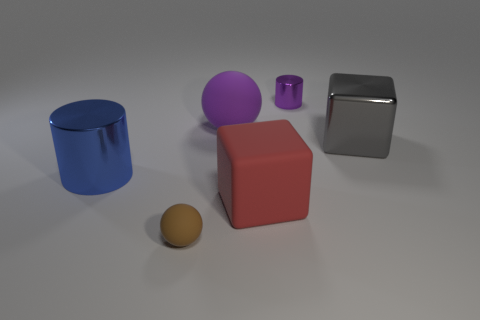Add 1 gray cylinders. How many objects exist? 7 Subtract all cylinders. How many objects are left? 4 Subtract 0 yellow cubes. How many objects are left? 6 Subtract all large purple rubber balls. Subtract all purple metallic cylinders. How many objects are left? 4 Add 3 metal cylinders. How many metal cylinders are left? 5 Add 1 blue shiny cylinders. How many blue shiny cylinders exist? 2 